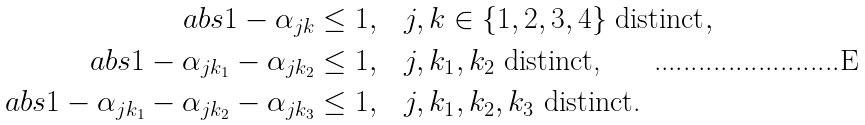Convert formula to latex. <formula><loc_0><loc_0><loc_500><loc_500>\ a b s { 1 - \alpha _ { j k } } \leq 1 , & \quad j , k \in \{ 1 , 2 , 3 , 4 \} \text { distinct} , \\ \ a b s { 1 - \alpha _ { j k _ { 1 } } - \alpha _ { j k _ { 2 } } } \leq 1 , & \quad j , k _ { 1 } , k _ { 2 } \text { distinct,} \\ \ a b s { 1 - \alpha _ { j k _ { 1 } } - \alpha _ { j k _ { 2 } } - \alpha _ { j k _ { 3 } } } \leq 1 , & \quad j , k _ { 1 } , k _ { 2 } , k _ { 3 } \text { distinct.}</formula> 